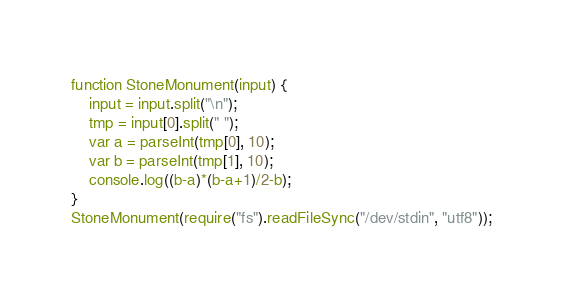Convert code to text. <code><loc_0><loc_0><loc_500><loc_500><_JavaScript_>function StoneMonument(input) {
    input = input.split("\n");
    tmp = input[0].split(" ");
    var a = parseInt(tmp[0], 10);
    var b = parseInt(tmp[1], 10);
    console.log((b-a)*(b-a+1)/2-b);
}
StoneMonument(require("fs").readFileSync("/dev/stdin", "utf8"));</code> 